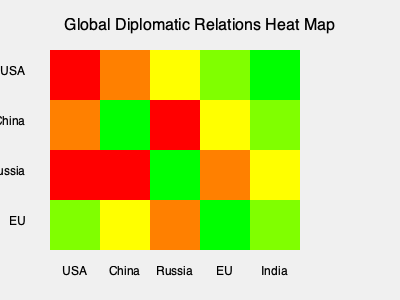Based on the heat map of global diplomatic relations, which country has the most strained relationship with Russia, and what potential implications could this have for your digital communication platform designed for diplomats? To answer this question, we need to analyze the heat map row by row:

1. Identify Russia's row:
   - The third row represents Russia's relations with other countries.

2. Analyze the colors in Russia's row:
   - Red: Most strained relationship
   - Orange: Strained relationship
   - Yellow: Neutral relationship
   - Light Green: Positive relationship
   - Dark Green: Strong positive relationship

3. Examine Russia's relationships:
   - USA: Red (most strained)
   - China: Red (most strained)
   - Russia: Dark Green (self-relation, not relevant)
   - EU: Orange (strained)
   - India: Yellow (neutral)

4. Determine the most strained relationship:
   - Both the USA and China have red squares, indicating equally strained relationships with Russia.

5. Consider implications for the digital communication platform:
   - Need for enhanced security features to protect sensitive diplomatic communications
   - Importance of real-time translation capabilities for US/China-Russia dialogues
   - Implementation of sentiment analysis tools to gauge the tone of communications
   - Development of crisis management modules for rapid response in tense situations
   - Integration of historical context and cultural sensitivity guidelines to aid diplomats in navigating complex relations

The platform should prioritize features that facilitate careful, secure, and nuanced communication between these nations to help manage and potentially improve strained diplomatic ties.
Answer: USA and China; enhanced security, translation, sentiment analysis, and crisis management features 